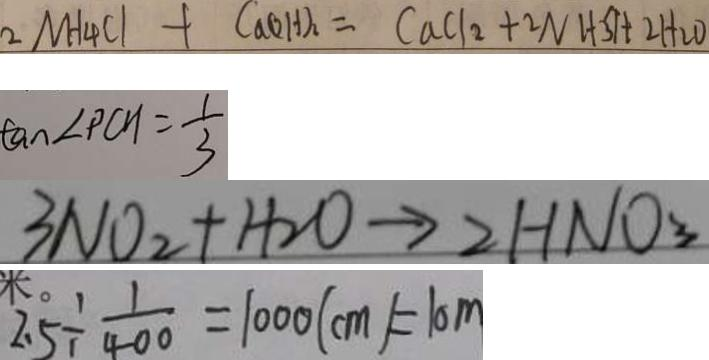<formula> <loc_0><loc_0><loc_500><loc_500>2 N H _ { 4 } C l + C a ( O H ) _ { 2 } = C a C l _ { 2 } + 2 N H _ { 3 } \uparrow + 2 H _ { 2 } O 
 \tan \angle P C H = \frac { 1 } { 3 } 
 3 N O _ { 2 } + H _ { 2 } O \rightarrow 2 H N O _ { 3 } 
 2 . 5 \div \frac { 1 } { 4 0 0 } = 1 0 0 0 ( c m ) = 1 0 m</formula> 